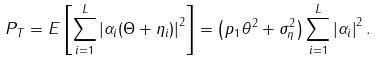<formula> <loc_0><loc_0><loc_500><loc_500>P _ { T } = E \left [ \sum _ { i = 1 } ^ { L } \left | \alpha _ { i } ( \Theta + \eta _ { i } ) \right | ^ { 2 } \right ] = \left ( p _ { 1 } \theta ^ { 2 } + \sigma _ { \eta } ^ { 2 } \right ) \sum _ { i = 1 } ^ { L } \left | \alpha _ { i } \right | ^ { 2 } .</formula> 